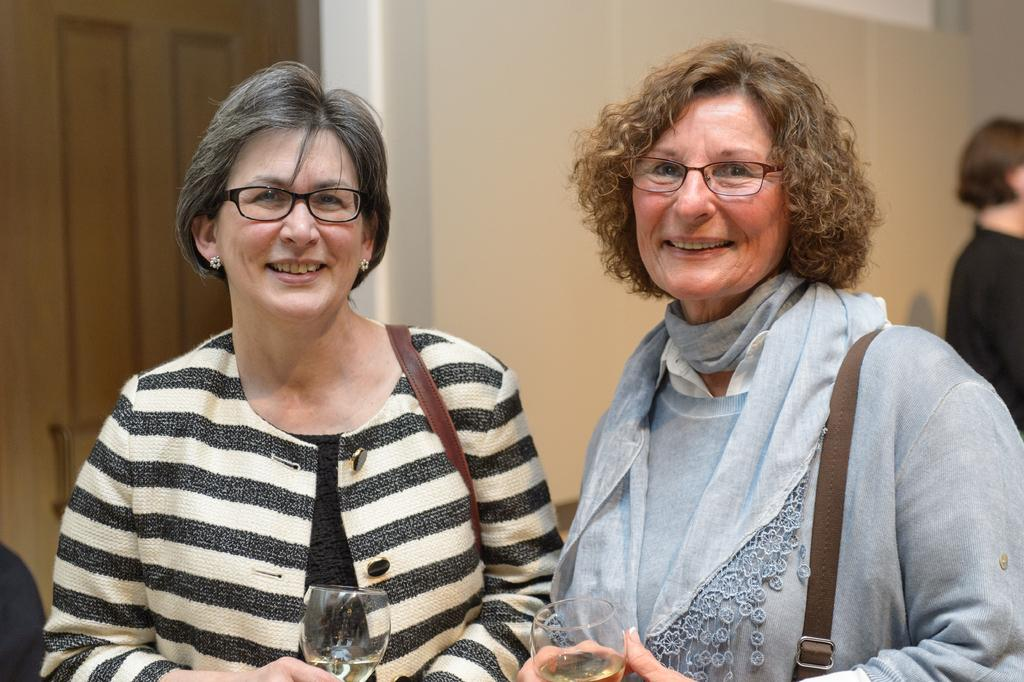How many people are in the image? There are two ladies in the image. What are the ladies wearing? The ladies are wearing handbags. What are the ladies holding in their hands? The ladies are holding glasses with wine in them. What can be seen in the background of the image? There is a wall and a door in the background of the image. What type of eggs are being taught by the ladies in the image? There are no eggs or teaching activities present in the image. 